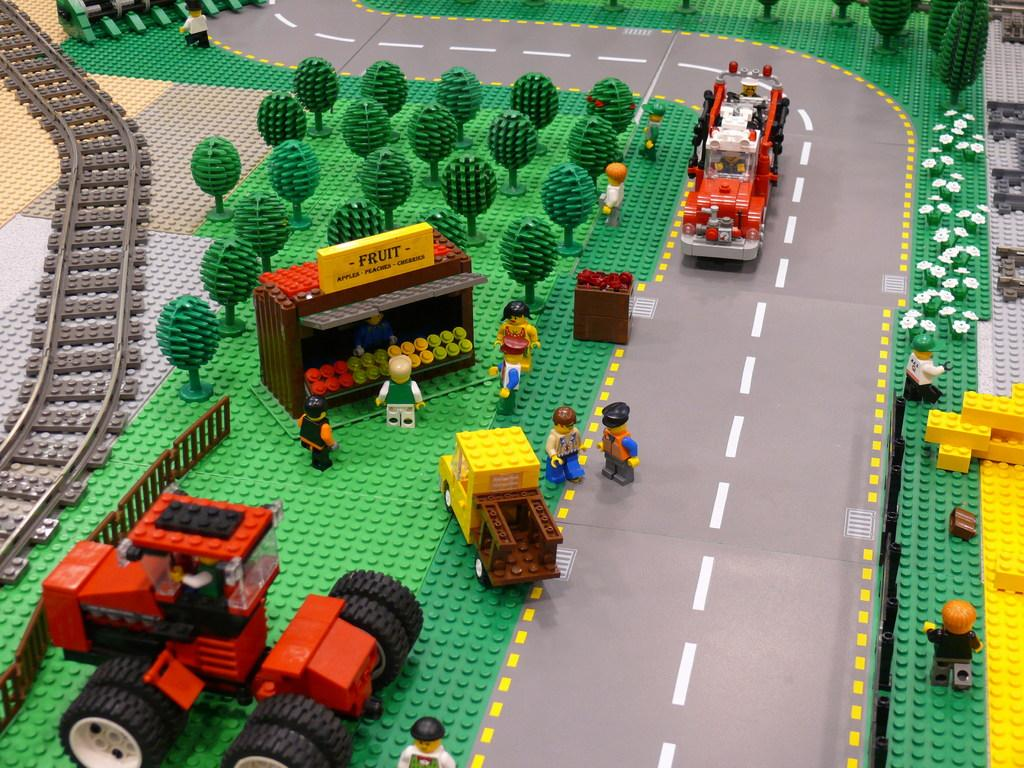<image>
Offer a succinct explanation of the picture presented. A Lego city has a FRUIT stand with apples, peaches, and cherries for sale 